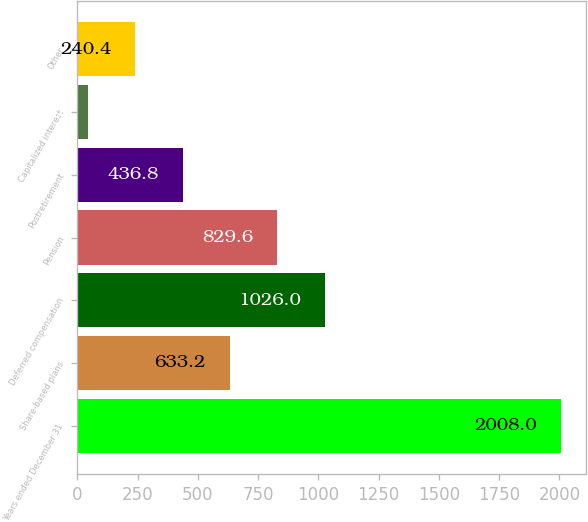Convert chart to OTSL. <chart><loc_0><loc_0><loc_500><loc_500><bar_chart><fcel>Years ended December 31<fcel>Share-based plans<fcel>Deferred compensation<fcel>Pension<fcel>Postretirement<fcel>Capitalized interest<fcel>Other<nl><fcel>2008<fcel>633.2<fcel>1026<fcel>829.6<fcel>436.8<fcel>44<fcel>240.4<nl></chart> 